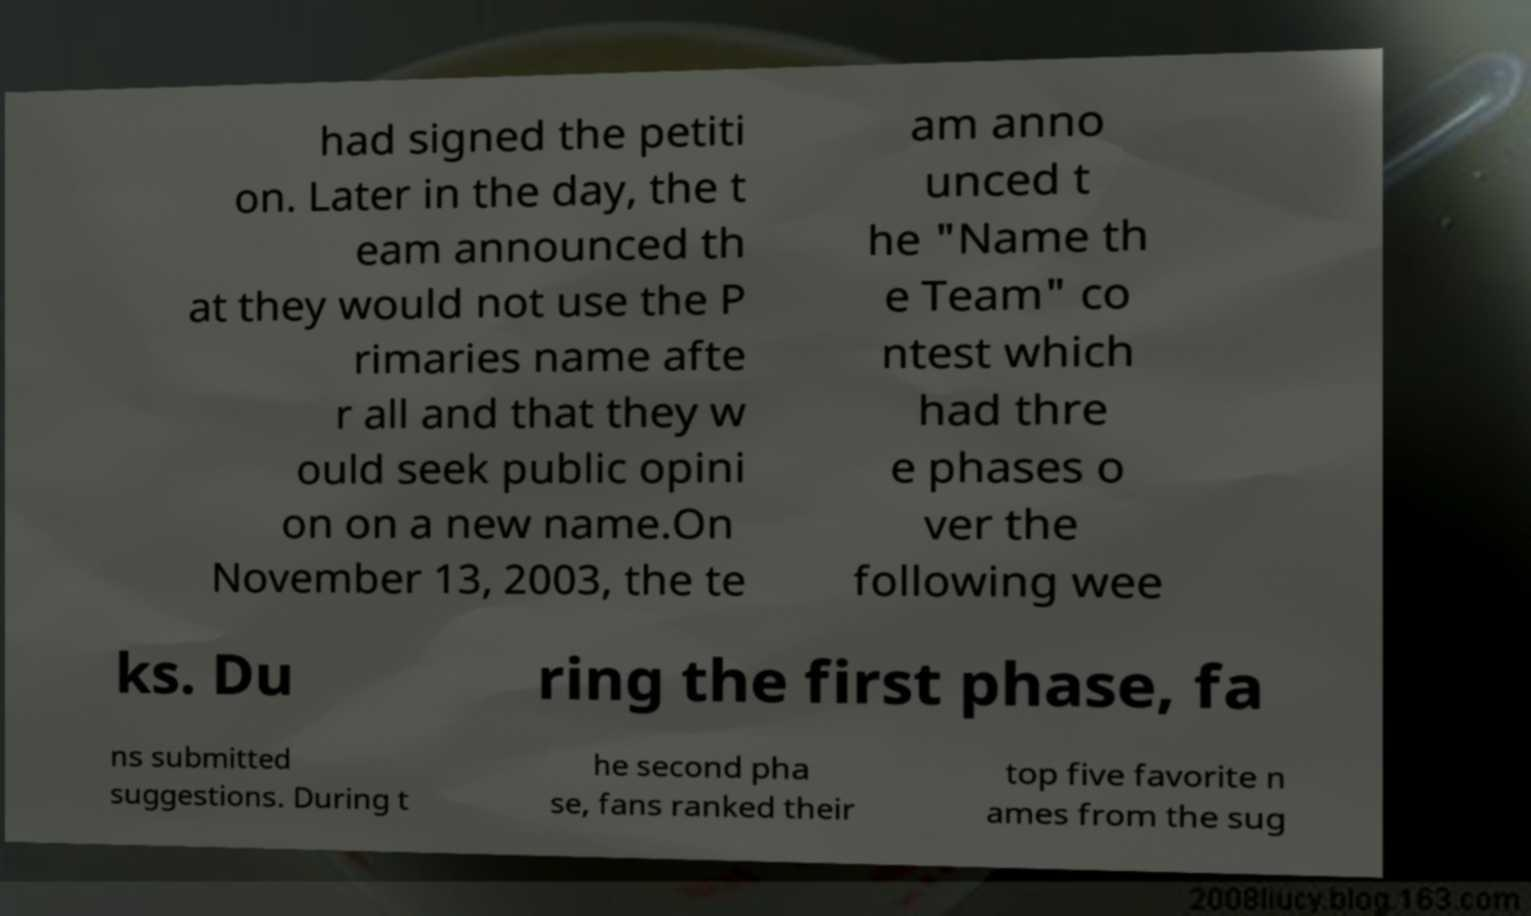Please identify and transcribe the text found in this image. had signed the petiti on. Later in the day, the t eam announced th at they would not use the P rimaries name afte r all and that they w ould seek public opini on on a new name.On November 13, 2003, the te am anno unced t he "Name th e Team" co ntest which had thre e phases o ver the following wee ks. Du ring the first phase, fa ns submitted suggestions. During t he second pha se, fans ranked their top five favorite n ames from the sug 